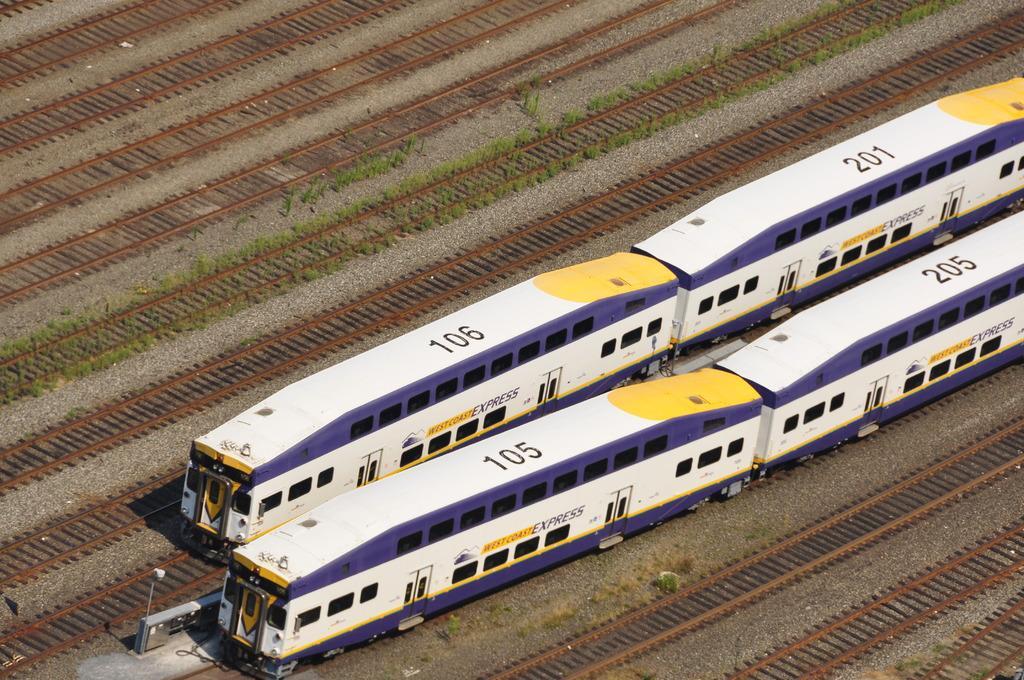How would you summarize this image in a sentence or two? In this picture we can observe two white and purple color trains moving on the railway tracks. We can observe many railway tracks here. There are some plants on the ground. 